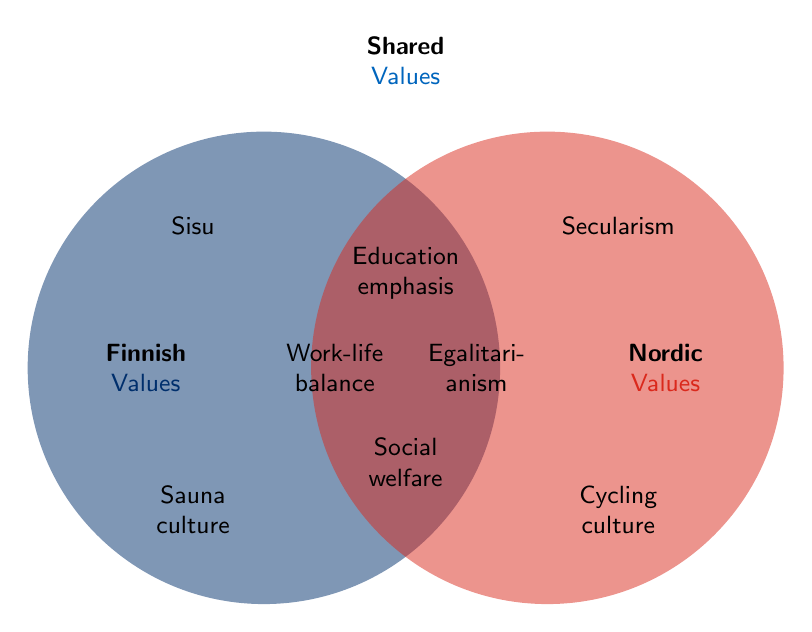What value is shared between both Finnish and Nordic cultures and is placed at the top center of the diagram? The value at the top center of the Venn Diagram represents a shared value between Finnish and Nordic cultures.
Answer: Education emphasis Which values are unique to Finnish culture as per the diagram? The values unique to Finnish culture are depicted in the left circle but outside of the overlapping region.
Answer: Traditional family values, National independence, Sauna culture, Sisu, Coffee consumption How many shared values are depicted in the diagram? The shared values are located in the intersection of the two circles. Counting these gives us the total number of shared values.
Answer: 5 Are there more unique Finnish values or more unique Nordic values in the diagram? To determine this, count the unique values in both Finnish and Nordic circles and then compare them.
Answer: Unique Finnish values What is one specific value associated only with Nordic culture? The values unique to Nordic culture are in the right circle but outside of the overlapping region.
Answer: Outdoor lifestyle (friluftsliv) Which values are listed at the intersection of the two circles? Values located at the intersection are common to both Finnish and Nordic cultures.
Answer: Social welfare, Environmental consciousness, Egalitarianism, Work-life balance, Education emphasis How does the count of shared values compare to the unique Finnish values? Count the number of shared values and the number of unique Finnish values, then analyze the difference.
Answer: Shared values: 5, Unique Finnish values: 5; equal count What value indicates a cultural emphasis on perseverance and is unique to Finnish culture? This value is on the left side, indicative of Finnish culture outside the overlapping region.
Answer: Sisu What is the common value found between Finnish and Nordic cultures related to society? This value is common to both cultures and relates to society, found in the intersection section.
Answer: Social welfare 